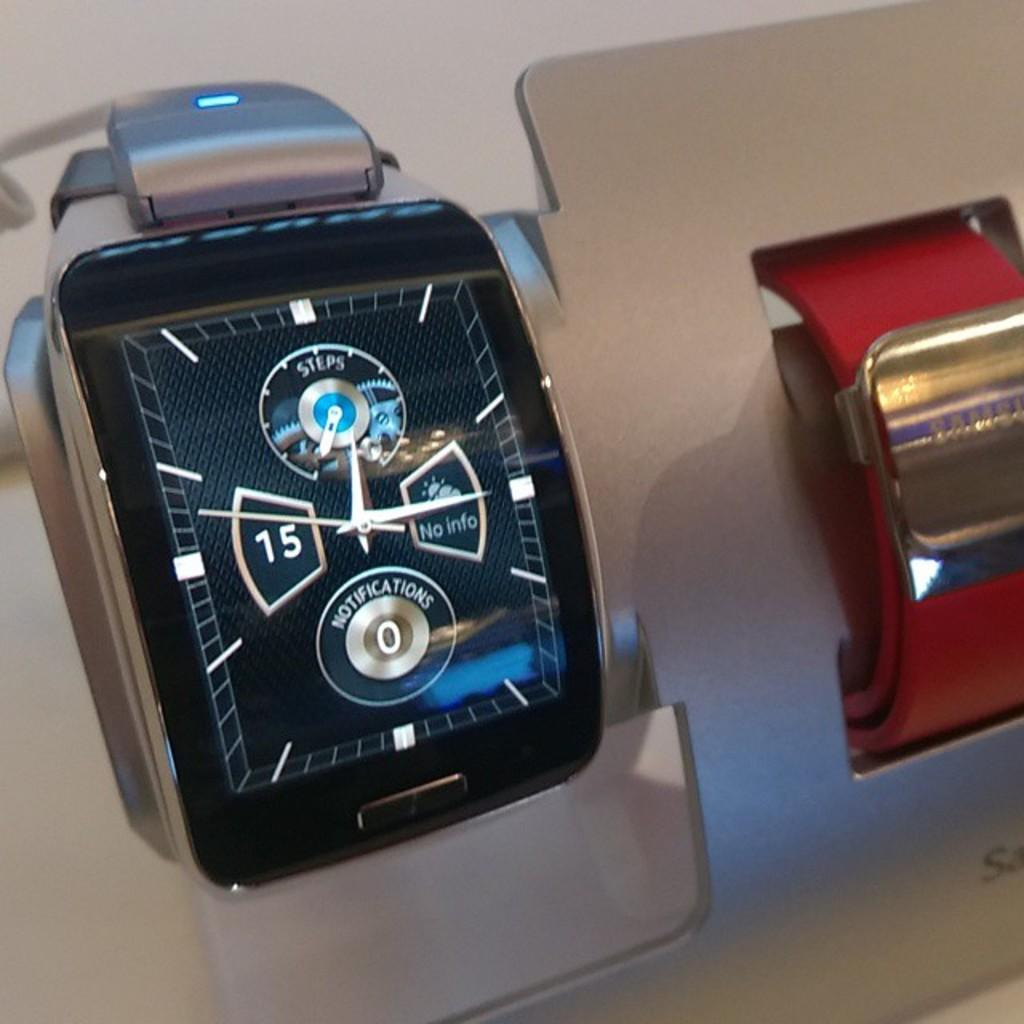<image>
Describe the image concisely. A smart watch shows no current notifications and no steps. 